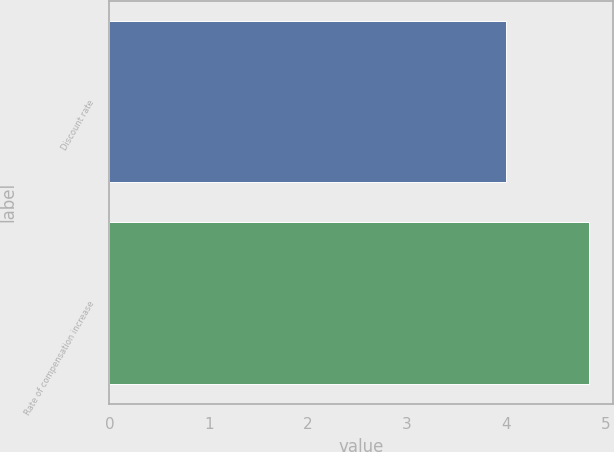Convert chart to OTSL. <chart><loc_0><loc_0><loc_500><loc_500><bar_chart><fcel>Discount rate<fcel>Rate of compensation increase<nl><fcel>4<fcel>4.83<nl></chart> 